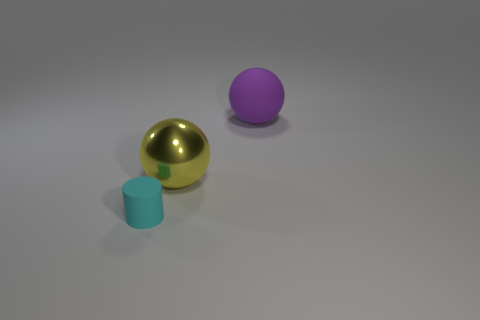Are there any other things that are made of the same material as the big yellow sphere?
Provide a succinct answer. No. Are the big purple object right of the metal object and the cyan cylinder made of the same material?
Give a very brief answer. Yes. What size is the thing to the left of the sphere that is left of the rubber thing that is to the right of the small cyan matte object?
Offer a terse response. Small. The cyan cylinder that is made of the same material as the big purple thing is what size?
Your answer should be very brief. Small. There is a object that is both in front of the big purple rubber thing and on the right side of the tiny cyan rubber thing; what color is it?
Your answer should be compact. Yellow. There is a rubber thing behind the metal ball; is its shape the same as the large thing that is left of the large purple ball?
Your answer should be very brief. Yes. There is a cyan thing that is on the left side of the large purple ball; what is it made of?
Provide a succinct answer. Rubber. What number of things are matte things behind the tiny cyan rubber object or large rubber spheres?
Make the answer very short. 1. Are there the same number of tiny cyan cylinders that are behind the yellow object and big matte objects?
Give a very brief answer. No. Do the purple thing and the yellow metallic object have the same size?
Provide a short and direct response. Yes. 